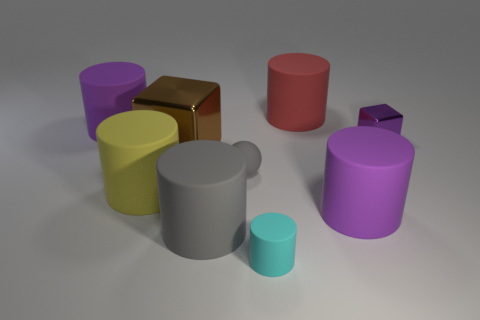How many gray things are either big spheres or large objects?
Keep it short and to the point. 1. Is there a small matte cylinder?
Ensure brevity in your answer.  Yes. There is a block to the left of the gray thing behind the big gray rubber thing; are there any big gray objects that are behind it?
Provide a short and direct response. No. Is there any other thing that has the same size as the yellow object?
Give a very brief answer. Yes. There is a big metallic object; is its shape the same as the tiny shiny object on the right side of the small gray rubber thing?
Offer a very short reply. Yes. There is a big matte cylinder that is in front of the purple cylinder right of the purple cylinder that is on the left side of the small matte cylinder; what color is it?
Provide a short and direct response. Gray. How many objects are large purple matte things to the right of the cyan cylinder or big rubber objects that are behind the big yellow matte object?
Provide a short and direct response. 3. How many other objects are there of the same color as the tiny metal thing?
Your answer should be very brief. 2. Is the shape of the gray rubber object behind the gray matte cylinder the same as  the small purple metal thing?
Your answer should be compact. No. Are there fewer matte cylinders to the left of the small cylinder than tiny purple cubes?
Your answer should be very brief. No. 